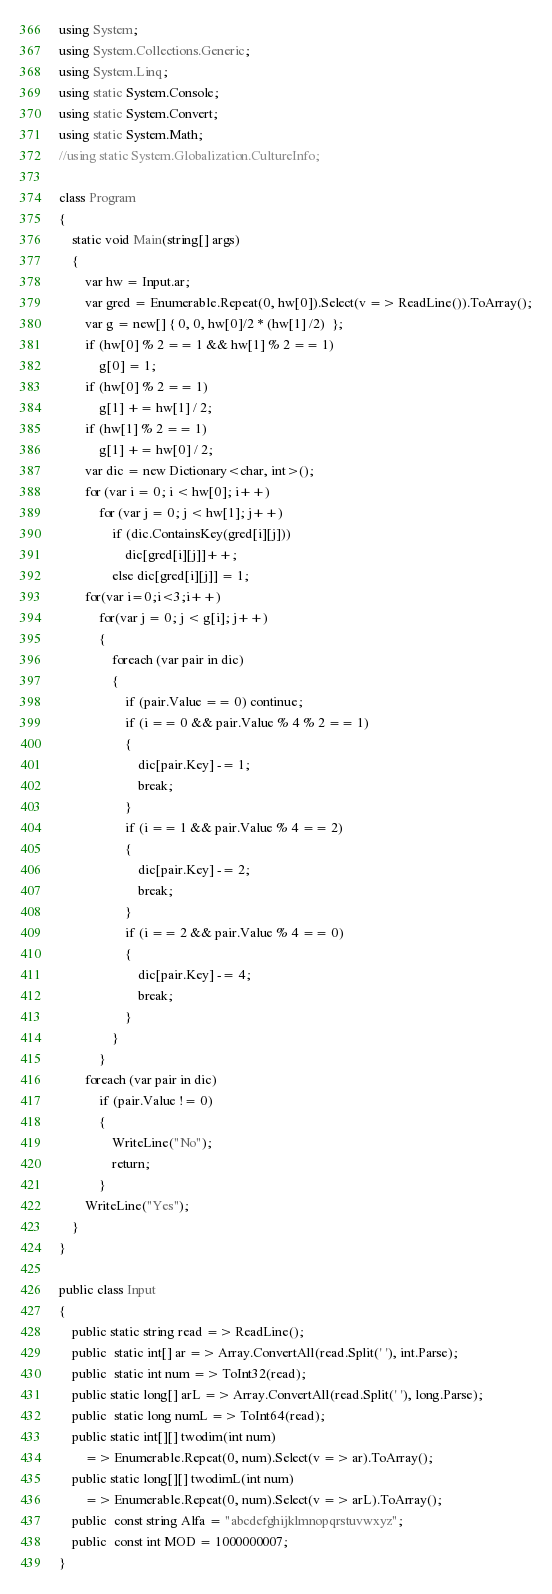Convert code to text. <code><loc_0><loc_0><loc_500><loc_500><_C#_>using System;
using System.Collections.Generic;
using System.Linq;
using static System.Console;
using static System.Convert;
using static System.Math;
//using static System.Globalization.CultureInfo;

class Program
{
    static void Main(string[] args)
    {
        var hw = Input.ar;
        var gred = Enumerable.Repeat(0, hw[0]).Select(v => ReadLine()).ToArray();
        var g = new[] { 0, 0, hw[0]/2 * (hw[1] /2)  };
        if (hw[0] % 2 == 1 && hw[1] % 2 == 1)
            g[0] = 1;
        if (hw[0] % 2 == 1)
            g[1] += hw[1] / 2;
        if (hw[1] % 2 == 1)
            g[1] += hw[0] / 2;
        var dic = new Dictionary<char, int>();
        for (var i = 0; i < hw[0]; i++)
            for (var j = 0; j < hw[1]; j++)
                if (dic.ContainsKey(gred[i][j]))
                    dic[gred[i][j]]++;
                else dic[gred[i][j]] = 1;
        for(var i=0;i<3;i++)
            for(var j = 0; j < g[i]; j++)
            {
                foreach (var pair in dic)
                {
                    if (pair.Value == 0) continue;
                    if (i == 0 && pair.Value % 4 % 2 == 1)
                    {
                        dic[pair.Key] -= 1;
                        break;
                    }
                    if (i == 1 && pair.Value % 4 == 2)
                    {
                        dic[pair.Key] -= 2;
                        break;
                    }
                    if (i == 2 && pair.Value % 4 == 0)
                    {
                        dic[pair.Key] -= 4;
                        break;
                    }
                }
            }
        foreach (var pair in dic)
            if (pair.Value != 0)
            {
                WriteLine("No");
                return;
            }
        WriteLine("Yes");
    }
}

public class Input
{
    public static string read => ReadLine();
    public  static int[] ar => Array.ConvertAll(read.Split(' '), int.Parse);
    public  static int num => ToInt32(read);
    public static long[] arL => Array.ConvertAll(read.Split(' '), long.Parse);
    public  static long numL => ToInt64(read);
    public static int[][] twodim(int num)
        => Enumerable.Repeat(0, num).Select(v => ar).ToArray();
    public static long[][] twodimL(int num)
        => Enumerable.Repeat(0, num).Select(v => arL).ToArray();
    public  const string Alfa = "abcdefghijklmnopqrstuvwxyz";
    public  const int MOD = 1000000007;
}
</code> 